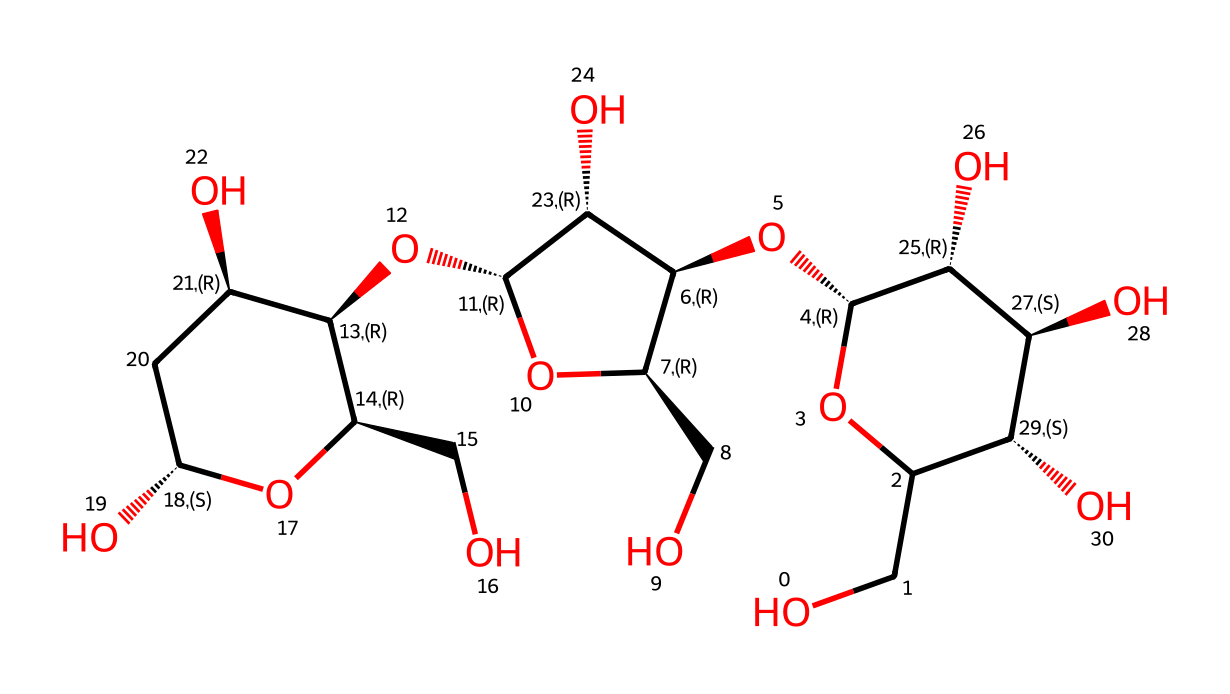What is the molecular formula of cellulose? Cellulose is a polysaccharide composed of glucose units. By analyzing the SMILES structure, we can count the number of carbon (C), hydrogen (H), and oxygen (O) atoms. In the structure, there are 6 carbon atoms, 10 hydrogen atoms, and 5 oxygen atoms, leading to the molecular formula C6H10O5, which represents cellulose.
Answer: C6H10O5 How many glucose units are present in cellulose? Cellulose is composed of linear chains of β-D-glucose units linked by glycosidic bonds. By examining the structure, we can identify that there are 3 repeating glucose units present in the primary chain structure of cellulose visible in the SMILES notation.
Answer: 3 What type of glycosidic linkage is found in cellulose? The SMILES structure reveals that the connection between glucose units is through a β-(1→4) glycosidic linkage, which connects the first carbon of one glucose unit to the fourth carbon of the next glucose unit. This type of linkage is characteristic of cellulose.
Answer: β-(1→4) What is the degree of polymerization of cellulose? The degree of polymerization refers to the number of repeating monomeric units in a polymer. From the visual analysis of the structure, we could determine that there are 3 repeating glucose residues in this particular structure of cellulose, indicating its degree of polymerization is 3.
Answer: 3 Which functional groups are present in cellulose? By observing the SMILES representation and the overall structure, various hydroxyl (-OH) groups are visible attached to the carbon atoms. These hydroxyls are pivotal in the chemical properties of cellulose, making it hydrophilic.
Answer: hydroxyl groups What is the primary role of cellulose in plants? Cellulose provides structural support to plant cell walls, enabling plants to maintain rigidity and shape. Therefore, upon analyzing its structure, we can confirm that cellulose functions as the main structural component in plant cell walls.
Answer: structural support How does the structure of cellulose affect its solubility? The long chains of glucose units connected by β-(1→4) glycosidic bonds create a fibrous structure that is insoluble in water. The presence of many hydroxyl groups enhances hydrogen bonding between chains, contributing to its insolubility. Thus, the arrangement of these bonds helps to explain the low solubility of cellulose.
Answer: insoluble 